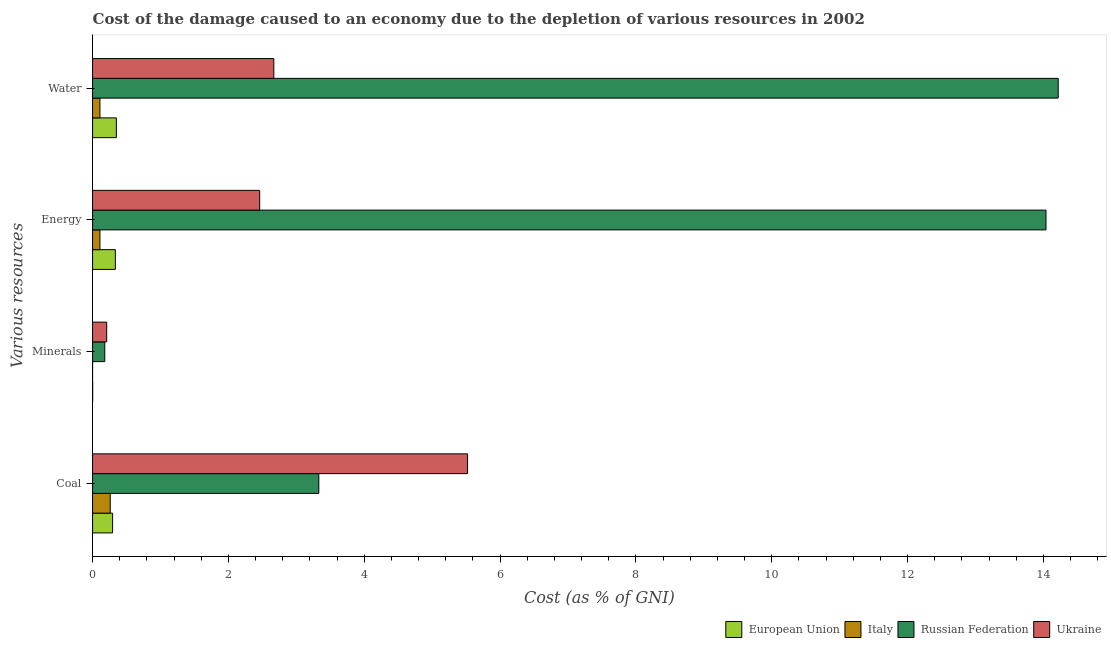How many groups of bars are there?
Keep it short and to the point. 4. What is the label of the 3rd group of bars from the top?
Make the answer very short. Minerals. What is the cost of damage due to depletion of energy in Italy?
Offer a very short reply. 0.11. Across all countries, what is the maximum cost of damage due to depletion of minerals?
Ensure brevity in your answer.  0.21. Across all countries, what is the minimum cost of damage due to depletion of water?
Offer a terse response. 0.11. In which country was the cost of damage due to depletion of water maximum?
Make the answer very short. Russian Federation. In which country was the cost of damage due to depletion of water minimum?
Offer a very short reply. Italy. What is the total cost of damage due to depletion of minerals in the graph?
Give a very brief answer. 0.39. What is the difference between the cost of damage due to depletion of minerals in Ukraine and that in Russian Federation?
Your answer should be compact. 0.03. What is the difference between the cost of damage due to depletion of minerals in European Union and the cost of damage due to depletion of coal in Russian Federation?
Your answer should be very brief. -3.33. What is the average cost of damage due to depletion of energy per country?
Offer a very short reply. 4.24. What is the difference between the cost of damage due to depletion of coal and cost of damage due to depletion of minerals in European Union?
Provide a short and direct response. 0.29. What is the ratio of the cost of damage due to depletion of minerals in Ukraine to that in Russian Federation?
Provide a short and direct response. 1.16. Is the difference between the cost of damage due to depletion of energy in Italy and European Union greater than the difference between the cost of damage due to depletion of water in Italy and European Union?
Ensure brevity in your answer.  Yes. What is the difference between the highest and the second highest cost of damage due to depletion of water?
Ensure brevity in your answer.  11.55. What is the difference between the highest and the lowest cost of damage due to depletion of energy?
Keep it short and to the point. 13.93. Is the sum of the cost of damage due to depletion of water in Russian Federation and Italy greater than the maximum cost of damage due to depletion of energy across all countries?
Keep it short and to the point. Yes. What does the 3rd bar from the top in Water represents?
Provide a succinct answer. Italy. What does the 2nd bar from the bottom in Minerals represents?
Offer a very short reply. Italy. Is it the case that in every country, the sum of the cost of damage due to depletion of coal and cost of damage due to depletion of minerals is greater than the cost of damage due to depletion of energy?
Ensure brevity in your answer.  No. How many bars are there?
Ensure brevity in your answer.  16. Are all the bars in the graph horizontal?
Offer a terse response. Yes. How many countries are there in the graph?
Offer a terse response. 4. Are the values on the major ticks of X-axis written in scientific E-notation?
Provide a short and direct response. No. Where does the legend appear in the graph?
Ensure brevity in your answer.  Bottom right. How many legend labels are there?
Give a very brief answer. 4. What is the title of the graph?
Your answer should be very brief. Cost of the damage caused to an economy due to the depletion of various resources in 2002 . What is the label or title of the X-axis?
Provide a short and direct response. Cost (as % of GNI). What is the label or title of the Y-axis?
Make the answer very short. Various resources. What is the Cost (as % of GNI) of European Union in Coal?
Your response must be concise. 0.3. What is the Cost (as % of GNI) of Italy in Coal?
Provide a succinct answer. 0.26. What is the Cost (as % of GNI) in Russian Federation in Coal?
Provide a succinct answer. 3.33. What is the Cost (as % of GNI) in Ukraine in Coal?
Ensure brevity in your answer.  5.52. What is the Cost (as % of GNI) of European Union in Minerals?
Provide a succinct answer. 0. What is the Cost (as % of GNI) of Italy in Minerals?
Keep it short and to the point. 5.86755790705434e-5. What is the Cost (as % of GNI) in Russian Federation in Minerals?
Make the answer very short. 0.18. What is the Cost (as % of GNI) of Ukraine in Minerals?
Keep it short and to the point. 0.21. What is the Cost (as % of GNI) in European Union in Energy?
Your answer should be compact. 0.34. What is the Cost (as % of GNI) in Italy in Energy?
Your response must be concise. 0.11. What is the Cost (as % of GNI) of Russian Federation in Energy?
Your answer should be very brief. 14.04. What is the Cost (as % of GNI) in Ukraine in Energy?
Your response must be concise. 2.46. What is the Cost (as % of GNI) of European Union in Water?
Offer a terse response. 0.35. What is the Cost (as % of GNI) in Italy in Water?
Keep it short and to the point. 0.11. What is the Cost (as % of GNI) in Russian Federation in Water?
Ensure brevity in your answer.  14.22. What is the Cost (as % of GNI) of Ukraine in Water?
Provide a succinct answer. 2.67. Across all Various resources, what is the maximum Cost (as % of GNI) in European Union?
Keep it short and to the point. 0.35. Across all Various resources, what is the maximum Cost (as % of GNI) of Italy?
Offer a very short reply. 0.26. Across all Various resources, what is the maximum Cost (as % of GNI) of Russian Federation?
Your answer should be compact. 14.22. Across all Various resources, what is the maximum Cost (as % of GNI) of Ukraine?
Make the answer very short. 5.52. Across all Various resources, what is the minimum Cost (as % of GNI) of European Union?
Your answer should be very brief. 0. Across all Various resources, what is the minimum Cost (as % of GNI) in Italy?
Keep it short and to the point. 5.86755790705434e-5. Across all Various resources, what is the minimum Cost (as % of GNI) in Russian Federation?
Give a very brief answer. 0.18. Across all Various resources, what is the minimum Cost (as % of GNI) in Ukraine?
Make the answer very short. 0.21. What is the total Cost (as % of GNI) in European Union in the graph?
Ensure brevity in your answer.  0.98. What is the total Cost (as % of GNI) in Italy in the graph?
Give a very brief answer. 0.48. What is the total Cost (as % of GNI) of Russian Federation in the graph?
Your answer should be very brief. 31.77. What is the total Cost (as % of GNI) in Ukraine in the graph?
Give a very brief answer. 10.86. What is the difference between the Cost (as % of GNI) of European Union in Coal and that in Minerals?
Ensure brevity in your answer.  0.29. What is the difference between the Cost (as % of GNI) of Italy in Coal and that in Minerals?
Your answer should be compact. 0.26. What is the difference between the Cost (as % of GNI) in Russian Federation in Coal and that in Minerals?
Your answer should be very brief. 3.15. What is the difference between the Cost (as % of GNI) in Ukraine in Coal and that in Minerals?
Your response must be concise. 5.31. What is the difference between the Cost (as % of GNI) in European Union in Coal and that in Energy?
Offer a terse response. -0.04. What is the difference between the Cost (as % of GNI) in Italy in Coal and that in Energy?
Offer a terse response. 0.15. What is the difference between the Cost (as % of GNI) in Russian Federation in Coal and that in Energy?
Provide a succinct answer. -10.71. What is the difference between the Cost (as % of GNI) of Ukraine in Coal and that in Energy?
Offer a very short reply. 3.06. What is the difference between the Cost (as % of GNI) in European Union in Coal and that in Water?
Provide a succinct answer. -0.06. What is the difference between the Cost (as % of GNI) of Italy in Coal and that in Water?
Offer a very short reply. 0.15. What is the difference between the Cost (as % of GNI) in Russian Federation in Coal and that in Water?
Offer a terse response. -10.89. What is the difference between the Cost (as % of GNI) in Ukraine in Coal and that in Water?
Provide a succinct answer. 2.85. What is the difference between the Cost (as % of GNI) in European Union in Minerals and that in Energy?
Your answer should be compact. -0.33. What is the difference between the Cost (as % of GNI) in Italy in Minerals and that in Energy?
Your answer should be very brief. -0.11. What is the difference between the Cost (as % of GNI) in Russian Federation in Minerals and that in Energy?
Provide a succinct answer. -13.86. What is the difference between the Cost (as % of GNI) in Ukraine in Minerals and that in Energy?
Make the answer very short. -2.25. What is the difference between the Cost (as % of GNI) in European Union in Minerals and that in Water?
Offer a terse response. -0.35. What is the difference between the Cost (as % of GNI) in Italy in Minerals and that in Water?
Your response must be concise. -0.11. What is the difference between the Cost (as % of GNI) in Russian Federation in Minerals and that in Water?
Make the answer very short. -14.04. What is the difference between the Cost (as % of GNI) of Ukraine in Minerals and that in Water?
Keep it short and to the point. -2.46. What is the difference between the Cost (as % of GNI) of European Union in Energy and that in Water?
Offer a terse response. -0.01. What is the difference between the Cost (as % of GNI) of Italy in Energy and that in Water?
Ensure brevity in your answer.  -0. What is the difference between the Cost (as % of GNI) of Russian Federation in Energy and that in Water?
Provide a short and direct response. -0.18. What is the difference between the Cost (as % of GNI) of Ukraine in Energy and that in Water?
Provide a succinct answer. -0.21. What is the difference between the Cost (as % of GNI) in European Union in Coal and the Cost (as % of GNI) in Italy in Minerals?
Keep it short and to the point. 0.3. What is the difference between the Cost (as % of GNI) in European Union in Coal and the Cost (as % of GNI) in Russian Federation in Minerals?
Provide a succinct answer. 0.12. What is the difference between the Cost (as % of GNI) in European Union in Coal and the Cost (as % of GNI) in Ukraine in Minerals?
Your answer should be compact. 0.09. What is the difference between the Cost (as % of GNI) in Italy in Coal and the Cost (as % of GNI) in Russian Federation in Minerals?
Give a very brief answer. 0.08. What is the difference between the Cost (as % of GNI) of Italy in Coal and the Cost (as % of GNI) of Ukraine in Minerals?
Offer a terse response. 0.05. What is the difference between the Cost (as % of GNI) of Russian Federation in Coal and the Cost (as % of GNI) of Ukraine in Minerals?
Ensure brevity in your answer.  3.12. What is the difference between the Cost (as % of GNI) of European Union in Coal and the Cost (as % of GNI) of Italy in Energy?
Offer a very short reply. 0.19. What is the difference between the Cost (as % of GNI) of European Union in Coal and the Cost (as % of GNI) of Russian Federation in Energy?
Give a very brief answer. -13.74. What is the difference between the Cost (as % of GNI) in European Union in Coal and the Cost (as % of GNI) in Ukraine in Energy?
Provide a succinct answer. -2.17. What is the difference between the Cost (as % of GNI) of Italy in Coal and the Cost (as % of GNI) of Russian Federation in Energy?
Your answer should be compact. -13.78. What is the difference between the Cost (as % of GNI) in Italy in Coal and the Cost (as % of GNI) in Ukraine in Energy?
Provide a short and direct response. -2.2. What is the difference between the Cost (as % of GNI) in Russian Federation in Coal and the Cost (as % of GNI) in Ukraine in Energy?
Your answer should be very brief. 0.87. What is the difference between the Cost (as % of GNI) in European Union in Coal and the Cost (as % of GNI) in Italy in Water?
Your response must be concise. 0.19. What is the difference between the Cost (as % of GNI) of European Union in Coal and the Cost (as % of GNI) of Russian Federation in Water?
Your answer should be compact. -13.92. What is the difference between the Cost (as % of GNI) in European Union in Coal and the Cost (as % of GNI) in Ukraine in Water?
Ensure brevity in your answer.  -2.37. What is the difference between the Cost (as % of GNI) of Italy in Coal and the Cost (as % of GNI) of Russian Federation in Water?
Provide a short and direct response. -13.96. What is the difference between the Cost (as % of GNI) in Italy in Coal and the Cost (as % of GNI) in Ukraine in Water?
Keep it short and to the point. -2.41. What is the difference between the Cost (as % of GNI) of Russian Federation in Coal and the Cost (as % of GNI) of Ukraine in Water?
Offer a very short reply. 0.66. What is the difference between the Cost (as % of GNI) of European Union in Minerals and the Cost (as % of GNI) of Italy in Energy?
Keep it short and to the point. -0.11. What is the difference between the Cost (as % of GNI) of European Union in Minerals and the Cost (as % of GNI) of Russian Federation in Energy?
Provide a succinct answer. -14.04. What is the difference between the Cost (as % of GNI) in European Union in Minerals and the Cost (as % of GNI) in Ukraine in Energy?
Offer a very short reply. -2.46. What is the difference between the Cost (as % of GNI) in Italy in Minerals and the Cost (as % of GNI) in Russian Federation in Energy?
Offer a terse response. -14.04. What is the difference between the Cost (as % of GNI) in Italy in Minerals and the Cost (as % of GNI) in Ukraine in Energy?
Make the answer very short. -2.46. What is the difference between the Cost (as % of GNI) in Russian Federation in Minerals and the Cost (as % of GNI) in Ukraine in Energy?
Your answer should be compact. -2.28. What is the difference between the Cost (as % of GNI) of European Union in Minerals and the Cost (as % of GNI) of Italy in Water?
Keep it short and to the point. -0.11. What is the difference between the Cost (as % of GNI) in European Union in Minerals and the Cost (as % of GNI) in Russian Federation in Water?
Your response must be concise. -14.22. What is the difference between the Cost (as % of GNI) in European Union in Minerals and the Cost (as % of GNI) in Ukraine in Water?
Your response must be concise. -2.67. What is the difference between the Cost (as % of GNI) of Italy in Minerals and the Cost (as % of GNI) of Russian Federation in Water?
Your response must be concise. -14.22. What is the difference between the Cost (as % of GNI) of Italy in Minerals and the Cost (as % of GNI) of Ukraine in Water?
Ensure brevity in your answer.  -2.67. What is the difference between the Cost (as % of GNI) of Russian Federation in Minerals and the Cost (as % of GNI) of Ukraine in Water?
Keep it short and to the point. -2.49. What is the difference between the Cost (as % of GNI) of European Union in Energy and the Cost (as % of GNI) of Italy in Water?
Provide a short and direct response. 0.23. What is the difference between the Cost (as % of GNI) in European Union in Energy and the Cost (as % of GNI) in Russian Federation in Water?
Give a very brief answer. -13.88. What is the difference between the Cost (as % of GNI) of European Union in Energy and the Cost (as % of GNI) of Ukraine in Water?
Give a very brief answer. -2.33. What is the difference between the Cost (as % of GNI) in Italy in Energy and the Cost (as % of GNI) in Russian Federation in Water?
Make the answer very short. -14.11. What is the difference between the Cost (as % of GNI) in Italy in Energy and the Cost (as % of GNI) in Ukraine in Water?
Offer a very short reply. -2.56. What is the difference between the Cost (as % of GNI) of Russian Federation in Energy and the Cost (as % of GNI) of Ukraine in Water?
Provide a succinct answer. 11.37. What is the average Cost (as % of GNI) of European Union per Various resources?
Offer a terse response. 0.25. What is the average Cost (as % of GNI) in Italy per Various resources?
Offer a very short reply. 0.12. What is the average Cost (as % of GNI) in Russian Federation per Various resources?
Offer a terse response. 7.94. What is the average Cost (as % of GNI) in Ukraine per Various resources?
Your response must be concise. 2.71. What is the difference between the Cost (as % of GNI) of European Union and Cost (as % of GNI) of Italy in Coal?
Keep it short and to the point. 0.04. What is the difference between the Cost (as % of GNI) of European Union and Cost (as % of GNI) of Russian Federation in Coal?
Your response must be concise. -3.04. What is the difference between the Cost (as % of GNI) of European Union and Cost (as % of GNI) of Ukraine in Coal?
Make the answer very short. -5.23. What is the difference between the Cost (as % of GNI) of Italy and Cost (as % of GNI) of Russian Federation in Coal?
Your answer should be compact. -3.07. What is the difference between the Cost (as % of GNI) in Italy and Cost (as % of GNI) in Ukraine in Coal?
Keep it short and to the point. -5.26. What is the difference between the Cost (as % of GNI) in Russian Federation and Cost (as % of GNI) in Ukraine in Coal?
Your answer should be very brief. -2.19. What is the difference between the Cost (as % of GNI) in European Union and Cost (as % of GNI) in Italy in Minerals?
Offer a very short reply. 0. What is the difference between the Cost (as % of GNI) of European Union and Cost (as % of GNI) of Russian Federation in Minerals?
Keep it short and to the point. -0.18. What is the difference between the Cost (as % of GNI) of European Union and Cost (as % of GNI) of Ukraine in Minerals?
Offer a very short reply. -0.21. What is the difference between the Cost (as % of GNI) in Italy and Cost (as % of GNI) in Russian Federation in Minerals?
Your answer should be compact. -0.18. What is the difference between the Cost (as % of GNI) of Italy and Cost (as % of GNI) of Ukraine in Minerals?
Make the answer very short. -0.21. What is the difference between the Cost (as % of GNI) in Russian Federation and Cost (as % of GNI) in Ukraine in Minerals?
Offer a terse response. -0.03. What is the difference between the Cost (as % of GNI) in European Union and Cost (as % of GNI) in Italy in Energy?
Provide a short and direct response. 0.23. What is the difference between the Cost (as % of GNI) of European Union and Cost (as % of GNI) of Russian Federation in Energy?
Your answer should be very brief. -13.7. What is the difference between the Cost (as % of GNI) in European Union and Cost (as % of GNI) in Ukraine in Energy?
Your response must be concise. -2.13. What is the difference between the Cost (as % of GNI) in Italy and Cost (as % of GNI) in Russian Federation in Energy?
Provide a succinct answer. -13.93. What is the difference between the Cost (as % of GNI) of Italy and Cost (as % of GNI) of Ukraine in Energy?
Offer a very short reply. -2.35. What is the difference between the Cost (as % of GNI) of Russian Federation and Cost (as % of GNI) of Ukraine in Energy?
Keep it short and to the point. 11.58. What is the difference between the Cost (as % of GNI) in European Union and Cost (as % of GNI) in Italy in Water?
Your answer should be compact. 0.24. What is the difference between the Cost (as % of GNI) of European Union and Cost (as % of GNI) of Russian Federation in Water?
Your answer should be very brief. -13.87. What is the difference between the Cost (as % of GNI) of European Union and Cost (as % of GNI) of Ukraine in Water?
Your answer should be very brief. -2.32. What is the difference between the Cost (as % of GNI) in Italy and Cost (as % of GNI) in Russian Federation in Water?
Provide a succinct answer. -14.11. What is the difference between the Cost (as % of GNI) of Italy and Cost (as % of GNI) of Ukraine in Water?
Your answer should be compact. -2.56. What is the difference between the Cost (as % of GNI) in Russian Federation and Cost (as % of GNI) in Ukraine in Water?
Your answer should be compact. 11.55. What is the ratio of the Cost (as % of GNI) of European Union in Coal to that in Minerals?
Your answer should be very brief. 181.63. What is the ratio of the Cost (as % of GNI) of Italy in Coal to that in Minerals?
Give a very brief answer. 4428.4. What is the ratio of the Cost (as % of GNI) of Russian Federation in Coal to that in Minerals?
Your answer should be very brief. 18.53. What is the ratio of the Cost (as % of GNI) of Ukraine in Coal to that in Minerals?
Keep it short and to the point. 26.56. What is the ratio of the Cost (as % of GNI) in European Union in Coal to that in Energy?
Your response must be concise. 0.88. What is the ratio of the Cost (as % of GNI) in Italy in Coal to that in Energy?
Give a very brief answer. 2.4. What is the ratio of the Cost (as % of GNI) of Russian Federation in Coal to that in Energy?
Give a very brief answer. 0.24. What is the ratio of the Cost (as % of GNI) in Ukraine in Coal to that in Energy?
Provide a short and direct response. 2.24. What is the ratio of the Cost (as % of GNI) in European Union in Coal to that in Water?
Your answer should be very brief. 0.84. What is the ratio of the Cost (as % of GNI) in Italy in Coal to that in Water?
Make the answer very short. 2.4. What is the ratio of the Cost (as % of GNI) in Russian Federation in Coal to that in Water?
Your response must be concise. 0.23. What is the ratio of the Cost (as % of GNI) of Ukraine in Coal to that in Water?
Make the answer very short. 2.07. What is the ratio of the Cost (as % of GNI) in European Union in Minerals to that in Energy?
Your response must be concise. 0. What is the ratio of the Cost (as % of GNI) in Russian Federation in Minerals to that in Energy?
Provide a short and direct response. 0.01. What is the ratio of the Cost (as % of GNI) in Ukraine in Minerals to that in Energy?
Ensure brevity in your answer.  0.08. What is the ratio of the Cost (as % of GNI) of European Union in Minerals to that in Water?
Offer a very short reply. 0. What is the ratio of the Cost (as % of GNI) in Russian Federation in Minerals to that in Water?
Your response must be concise. 0.01. What is the ratio of the Cost (as % of GNI) in Ukraine in Minerals to that in Water?
Offer a terse response. 0.08. What is the ratio of the Cost (as % of GNI) in European Union in Energy to that in Water?
Give a very brief answer. 0.96. What is the ratio of the Cost (as % of GNI) of Russian Federation in Energy to that in Water?
Offer a very short reply. 0.99. What is the ratio of the Cost (as % of GNI) in Ukraine in Energy to that in Water?
Give a very brief answer. 0.92. What is the difference between the highest and the second highest Cost (as % of GNI) in European Union?
Your answer should be very brief. 0.01. What is the difference between the highest and the second highest Cost (as % of GNI) of Italy?
Make the answer very short. 0.15. What is the difference between the highest and the second highest Cost (as % of GNI) of Russian Federation?
Your response must be concise. 0.18. What is the difference between the highest and the second highest Cost (as % of GNI) of Ukraine?
Your answer should be compact. 2.85. What is the difference between the highest and the lowest Cost (as % of GNI) of European Union?
Offer a very short reply. 0.35. What is the difference between the highest and the lowest Cost (as % of GNI) in Italy?
Your answer should be compact. 0.26. What is the difference between the highest and the lowest Cost (as % of GNI) of Russian Federation?
Ensure brevity in your answer.  14.04. What is the difference between the highest and the lowest Cost (as % of GNI) in Ukraine?
Your answer should be compact. 5.31. 